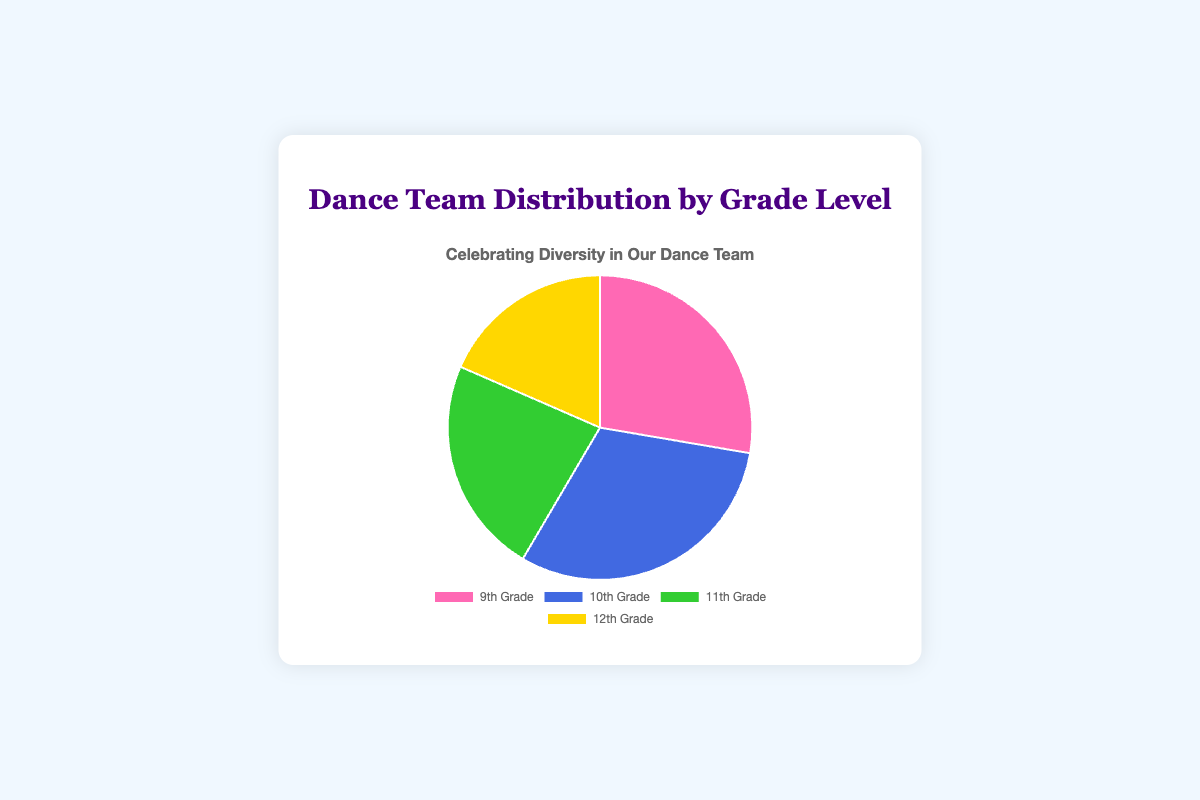What grade level has the highest number of dance team members? The chart shows the distribution of team members across grades. The largest segment belongs to the 10th Grade, which visually appears the largest.
Answer: 10th Grade How many more dance team members are there in 10th Grade compared to 12th Grade? The 10th Grade has 20 members, while the 12th Grade has 12 members. The difference is 20 - 12.
Answer: 8 What percentage of the dance team is comprised of 9th Grade members? The total number of members is 18 (9th) + 20 (10th) + 15 (11th) + 12 (12th) = 65. The percentage for 9th Grade is (18 / 65) * 100.
Answer: Approximately 27.7% Which grade level has the smallest representation on the dance team? Observing the chart, the smallest segment belongs to the 12th Grade.
Answer: 12th Grade If you combine members from 9th and 11th Grades, how many members are in total? The combined total is 18 (9th Grade) + 15 (11th Grade).
Answer: 33 What is the difference in membership between the grades with the most and least members? The grade with the most members is 10th Grade (20 members), and the least is 12th Grade (12 members). The difference is 20 - 12.
Answer: 8 What fraction of the dance team does the 11th Grade make up? The total number of members is 65. The fraction for 11th Grade is 15 / 65.
Answer: 3/13 Which two consecutive grades have the closest number of members? By comparing the member counts of consecutive grades: 9th (18) to 10th (20) = 2, 10th (20) to 11th (15) = 5, 11th (15) to 12th (12) = 3. The closest difference is between 9th and 10th Grade.
Answer: 9th and 10th Grade What is the average number of members per grade level on the team? The total number of members is 65, and there are 4 grade levels. The average is 65/4.
Answer: 16.25 By visual inspection, which grade's section is represented by a green segment on the pie chart? The green segment on the pie chart corresponds to the 11th Grade.
Answer: 11th Grade 